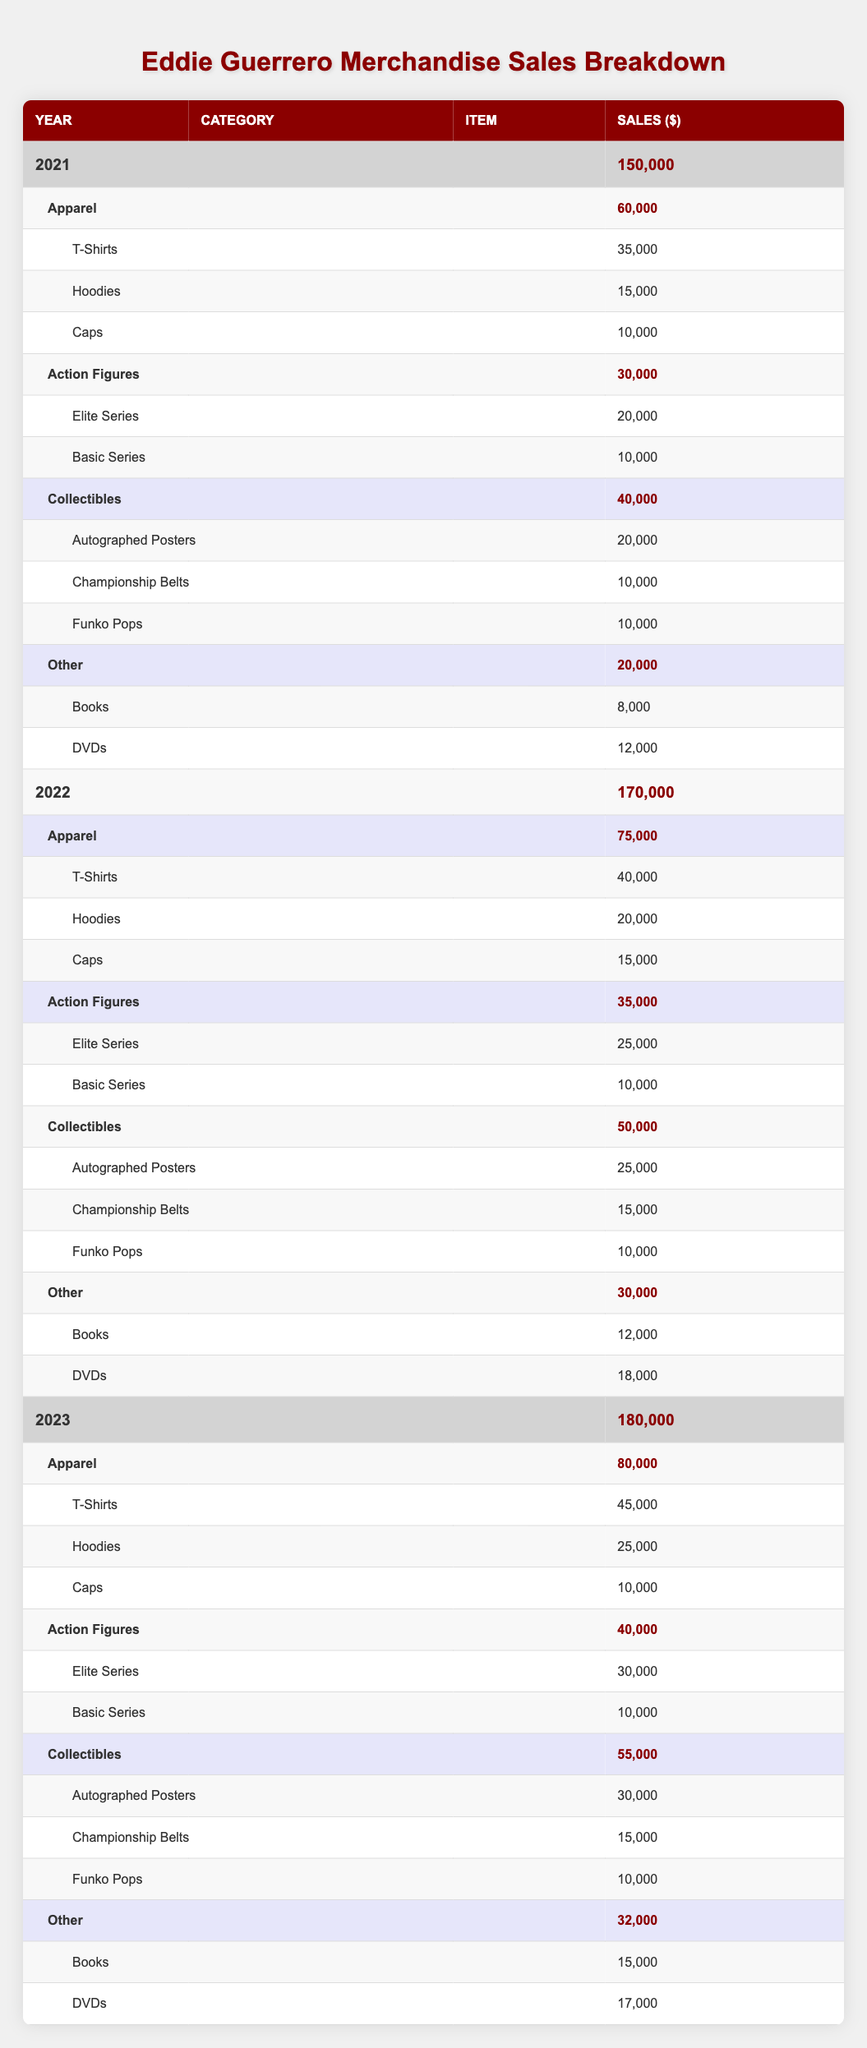What were the total merchandise sales in 2022? The total merchandise sales for 2022 is directly found in the table under the year 2022, which shows a total of 170,000.
Answer: 170,000 Which category had the highest sales in 2023? By reviewing the sales figures for each category in 2023, Apparel had the highest sales totaling 80,000, compared to other categories like Action Figures (40,000), Collectibles (55,000), and Other (32,000).
Answer: Apparel How much more did Collectibles sell in 2023 compared to 2021? In 2023, Collectibles sold 55,000, whereas in 2021, they sold 40,000. The difference is calculated as 55,000 - 40,000 = 15,000, showing that Collectibles sold 15,000 more in 2023 than in 2021.
Answer: 15,000 Did Eddie Guerrero merchandise sales increase every year from 2021 to 2023? By examining the total sales for each year: 2021 (150,000), 2022 (170,000), and 2023 (180,000), we can see that sales increased consistently in each year, confirming a yearly increase.
Answer: Yes What was the percentage of T-Shirt sales in total sales for the year 2022? T-Shirts sold 40,000 in 2022. To find the percentage of T-Shirt sales, we calculate (40,000 / 170,000) * 100, which equals 23.53%. This indicates T-Shirts made up approximately 23.53% of total sales in 2022.
Answer: 23.53% How much did Action Figures sales decrease from 2022 to 2023? Action Figures sales were 35,000 in 2022 and 40,000 in 2023. Since this is actually an increase, we confirm there is no decrease. Thus, the calculation of decrease is 35,000 - 40,000 = -5,000 showing sales increased by 5,000 from 2022 to 2023.
Answer: No decrease Which year saw the highest sales for other merchandise items? By checking the total for the Other category across the years, we find: 2021 (20,000), 2022 (30,000), and 2023 (32,000). Therefore, the highest sales for Other merchandise were in 2023.
Answer: 2023 What is the combined total sales for Elite Series from 2021 to 2023? The sales figures for Elite Series are: 20,000 in 2021, 25,000 in 2022, and 30,000 in 2023. To get the combined total, we sum these values: 20,000 + 25,000 + 30,000 = 75,000.
Answer: 75,000 What category had the least sales in 2021? Reviewing the categories for 2021, the Other category's total is 20,000, which is less than the totals for Apparel (60,000), Action Figures (30,000), and Collectibles (40,000). Therefore, Other had the least sales in 2021.
Answer: Other 